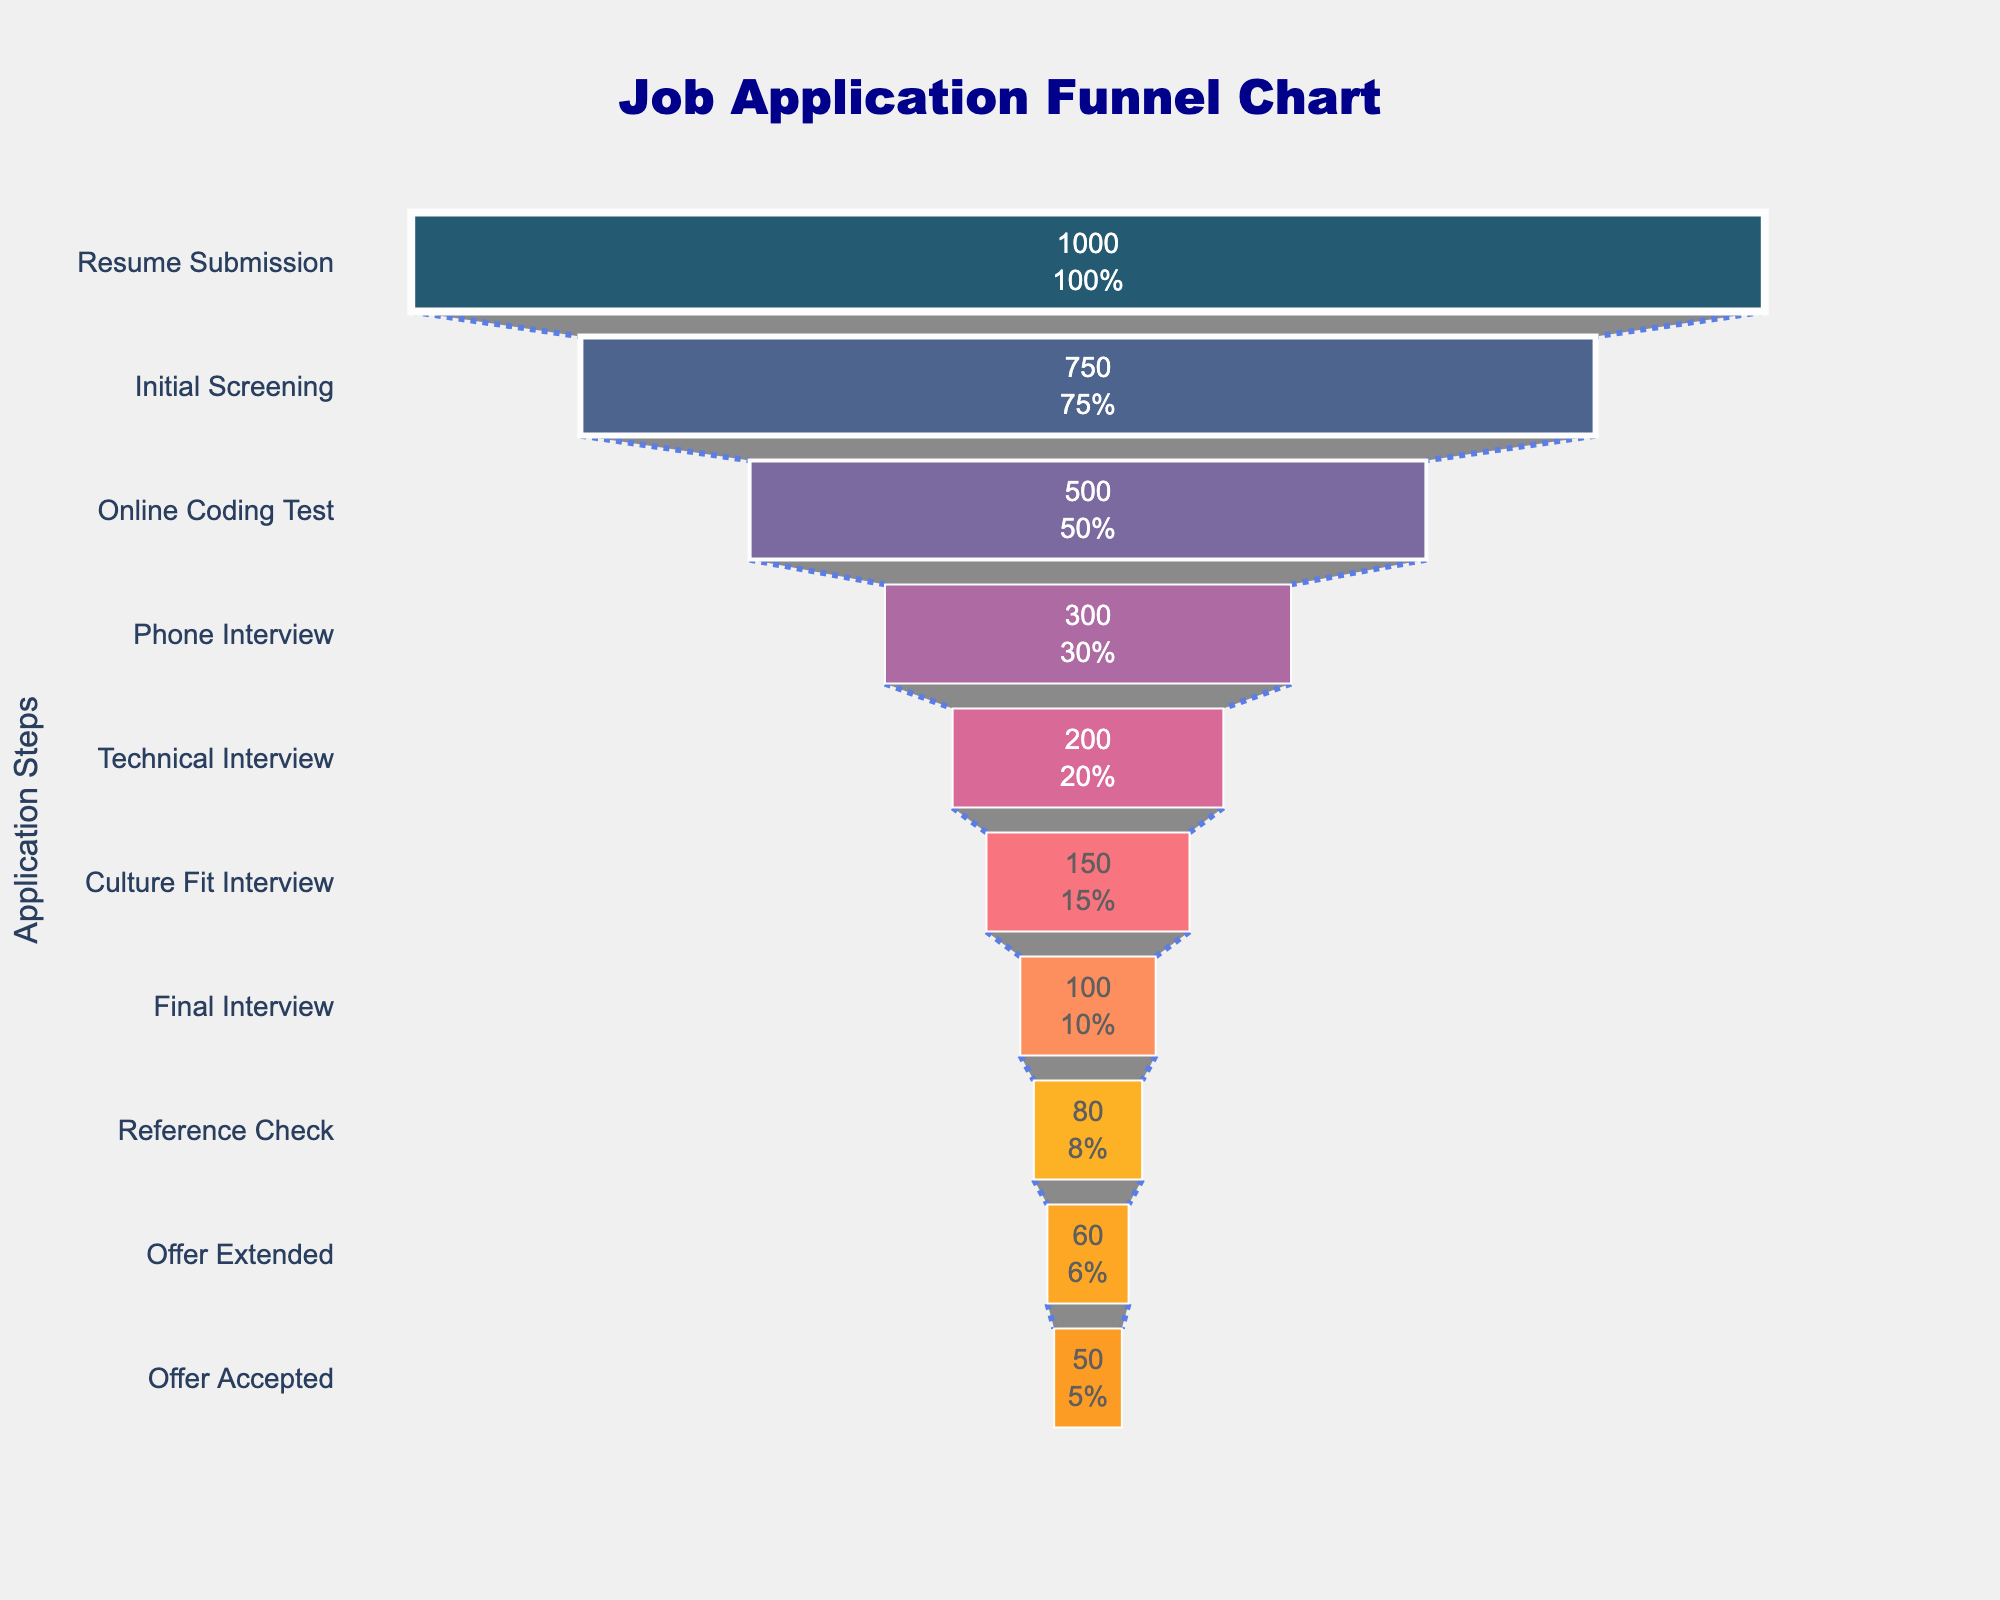What is the title of the funnel chart? The title of the chart is displayed at the top of the figure and is usually prominent. Look at the top-center part of the funnel chart to find the title.
Answer: Job Application Funnel Chart How many applicants were there at the "Technical Interview" step? Look for the "Technical Interview" step on the y-axis and read the corresponding number of applicants on the x-axis.
Answer: 200 Which step has the highest number of applicants? To identify the step with the most applicants, look for the step at the top of the funnel chart. This will be the largest bar in the visual representation.
Answer: Resume Submission What percentage of total applicants made it past the "Phone Interview" stage? Find the number of applicants at the "Phone Interview" stage and divide it by the total number of applicants (Resume Submission), then multiply by 100. The number of applicants at the "Phone Interview" stage is 300, and at the "Resume Submission" stage is 1000. (300/1000) * 100 = 30%
Answer: 30% How many applicants did not make it past the "Online Coding Test" stage? Subtract the number of applicants who passed the "Online Coding Test" (500) from the number who entered it (750). 750 - 500 = 250
Answer: 250 Compare the number of applicants at the "Initial Screening" and "Culture Fit Interview" steps. Which step has more applicants? Identify the number of applicants at both steps from the x-axis and compare them. "Initial Screening" has 750, and "Culture Fit Interview" has 150.
Answer: Initial Screening What is the difference in the number of applicants between the "Reference Check" stage and the "Final Interview" stage? Subtract the number of applicants at the "Final Interview" stage (100) from those at the "Reference Check" stage (80). 100 - 80 = 20
Answer: 20 Which stage in the funnel has the highest drop-off rate in terms of the number of applicants lost? Calculate the drop-off between each consecutive stage by subtracting the number of applicants at the current stage from the previous stage, then identify the maximum difference. Calculate differences between each stage and identify the largest one, which is between "Initial Screening" and "Online Coding Test": 750 - 500 = 250
Answer: Initial Screening to Online Coding Test What percentage of candidates accepted the job offer out of those who received an offer? Divide the number of candidates who accepted the offer (50) by the number who received the offer (60), then multiply by 100. (50/60) * 100 = 83.33%
Answer: 83.33% How many steps are there in the job application process? Count the number of distinct steps listed on the y-axis of the funnel chart.
Answer: 10 